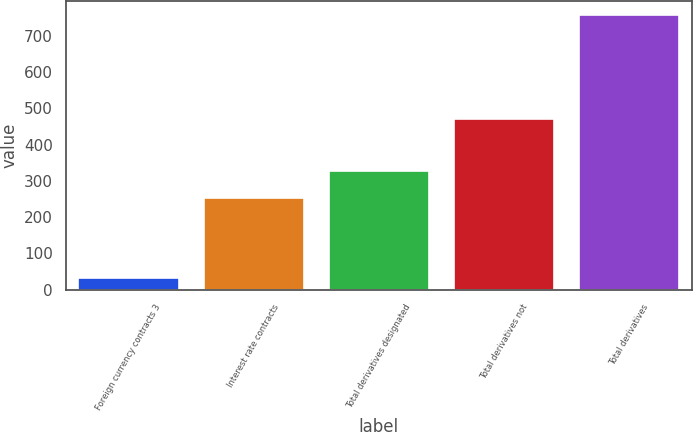<chart> <loc_0><loc_0><loc_500><loc_500><bar_chart><fcel>Foreign currency contracts 3<fcel>Interest rate contracts<fcel>Total derivatives designated<fcel>Total derivatives not<fcel>Total derivatives<nl><fcel>32<fcel>254<fcel>326.5<fcel>471<fcel>757<nl></chart> 